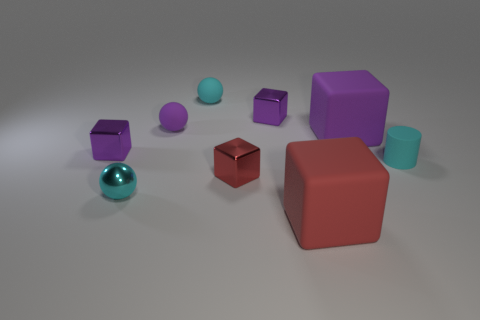How does the lighting affect the appearance of the objects? The lighting in the image creates soft shadows and subtle reflections, especially noticeable on the metallic sphere and the smooth surfaces of the cubes. It gives the scene a calm and balanced ambiance.  What mood does the arrangement of objects convey? The arrangement of objects, with varying shapes and muted colors positioned at different angles, conveys a sense of quiet order and an almost playful experimentation with geometry and space. 